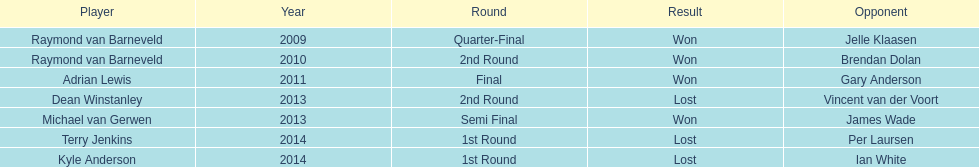Who were the athletes in 2014? Terry Jenkins, Kyle Anderson. Did they triumph or suffer a loss? Per Laursen. 